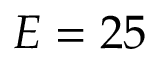Convert formula to latex. <formula><loc_0><loc_0><loc_500><loc_500>E = 2 5</formula> 